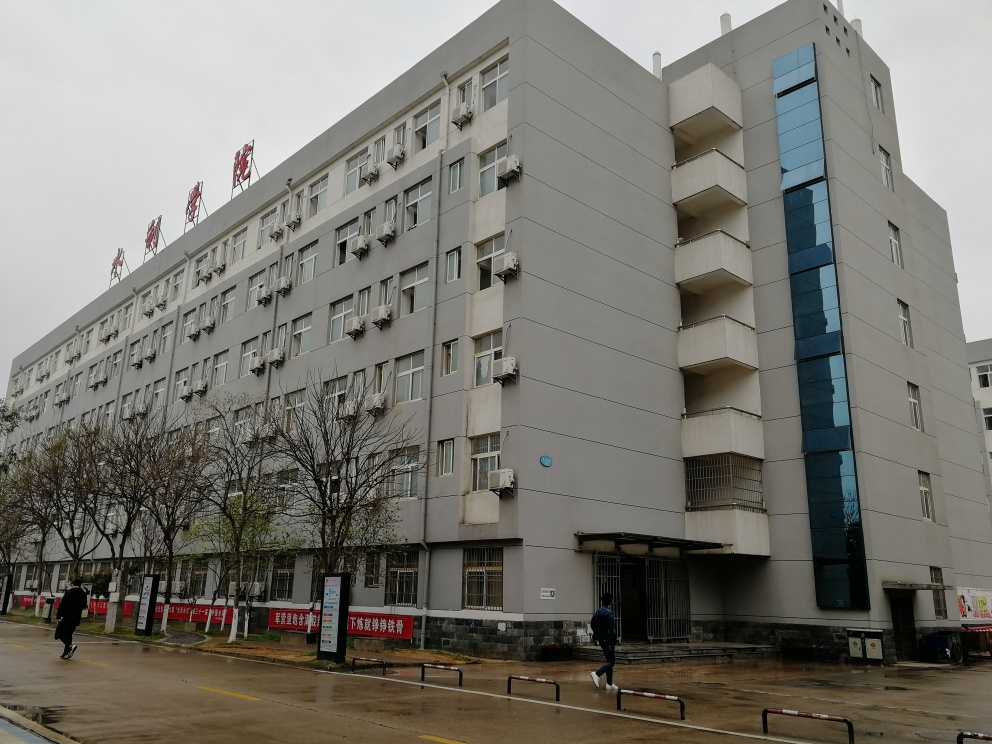What style of architecture does the building in the image represent? The architecture of the building appears utilitarian, with a functional and straightforward design. This style is often characterized by its lack of decorative elements, favoring clean lines and simplicity. The blue vertical feature adds a slight modern touch to the otherwise plain facade. 